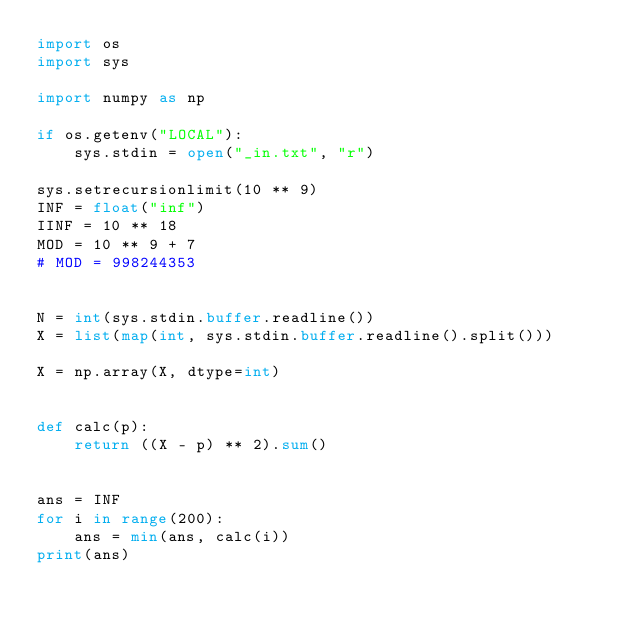<code> <loc_0><loc_0><loc_500><loc_500><_Python_>import os
import sys

import numpy as np

if os.getenv("LOCAL"):
    sys.stdin = open("_in.txt", "r")

sys.setrecursionlimit(10 ** 9)
INF = float("inf")
IINF = 10 ** 18
MOD = 10 ** 9 + 7
# MOD = 998244353


N = int(sys.stdin.buffer.readline())
X = list(map(int, sys.stdin.buffer.readline().split()))

X = np.array(X, dtype=int)


def calc(p):
    return ((X - p) ** 2).sum()


ans = INF
for i in range(200):
    ans = min(ans, calc(i))
print(ans)
</code> 